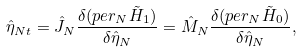<formula> <loc_0><loc_0><loc_500><loc_500>\hat { \eta } _ { N t } = \hat { J } _ { N } \frac { \delta ( p e r _ { N } \tilde { H } _ { 1 } ) } { \delta \hat { \eta } _ { N } } = \hat { M } _ { N } \frac { \delta ( p e r _ { N } \tilde { H } _ { 0 } ) } { \delta \hat { \eta } _ { N } } ,</formula> 